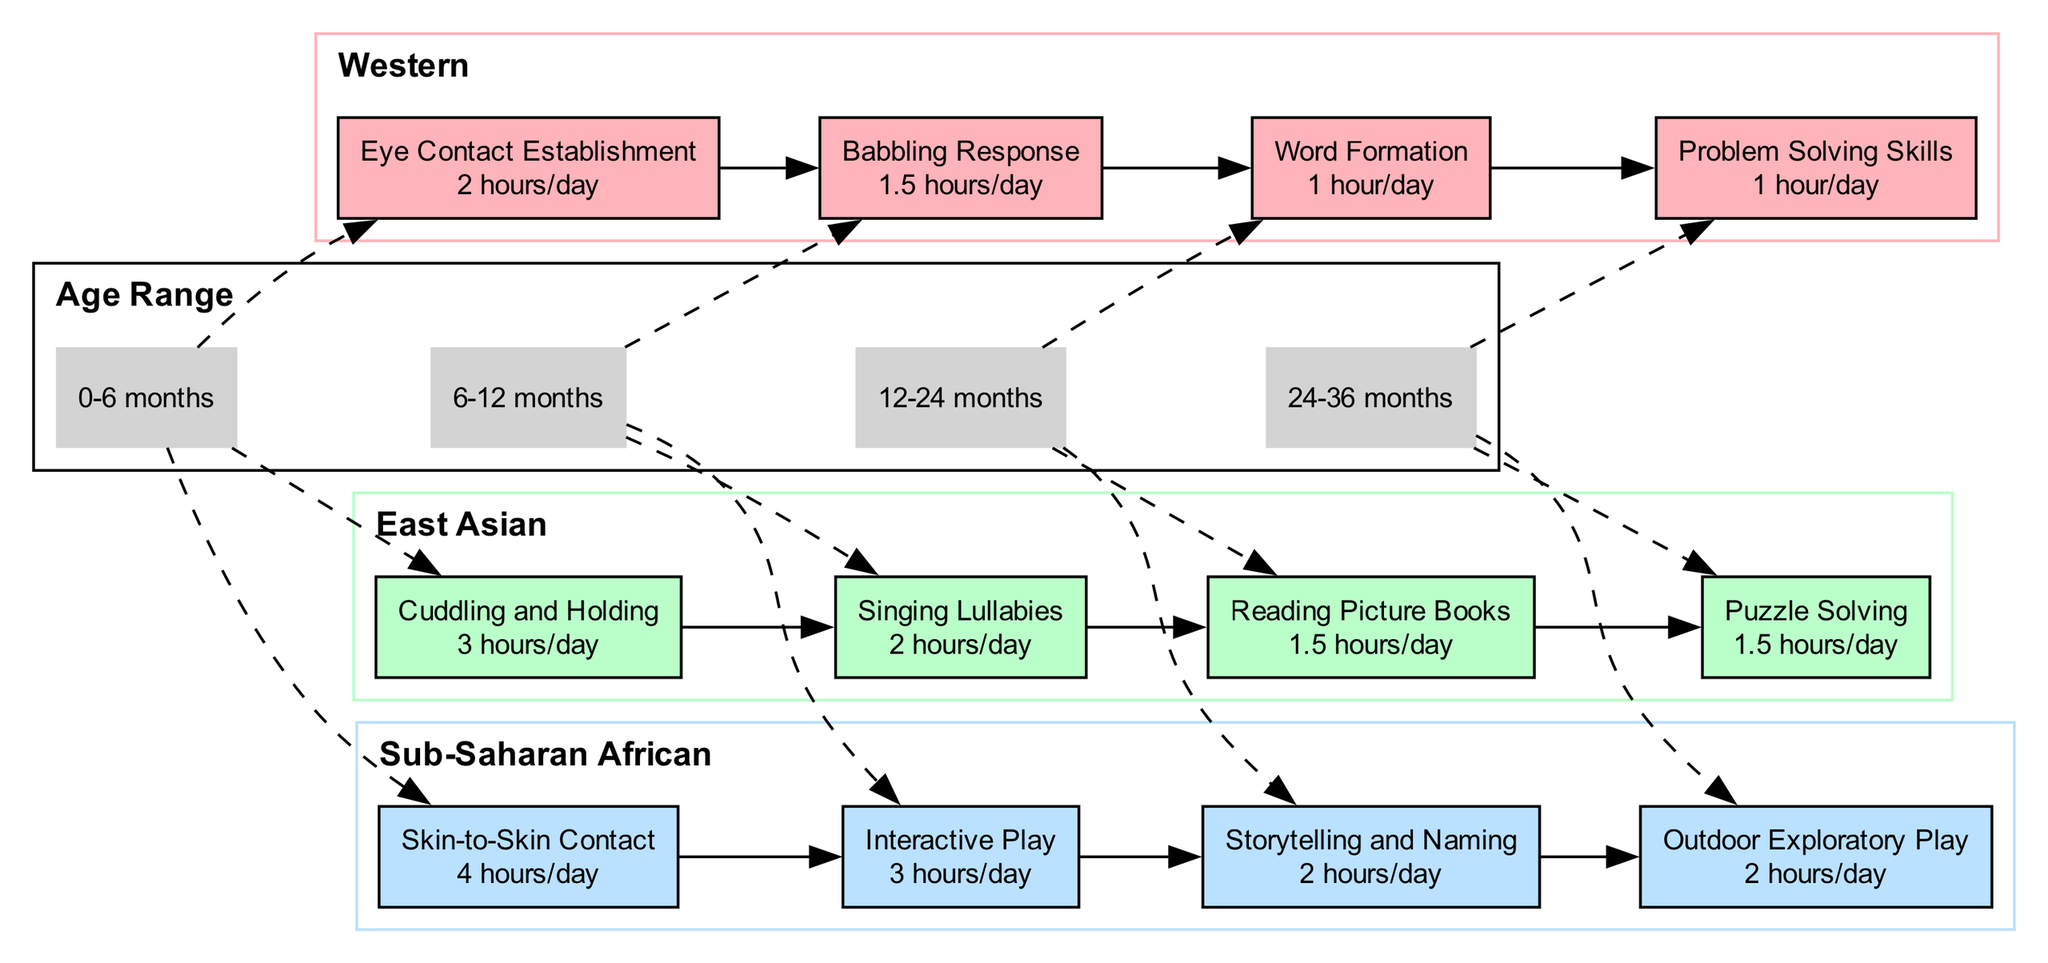What is the interaction time for eye contact establishment in the Western society? The diagram shows that the milestone for eye contact establishment in the Western society is linked to the age range of 0-6 months, where the interaction time is specified as 2 hours/day.
Answer: 2 hours/day Which society has the highest interaction time for cuddling and holding? By examining the milestones for the age range of 0-6 months, it is noted that Sub-Saharan African society has the highest interaction time for cuddling and holding, which is 4 hours/day.
Answer: 4 hours/day What are the milestones for East Asian society during the age range of 12-24 months? The diagram indicates that during the age range of 12-24 months, East Asian society's milestones include Reading Picture Books with an interaction time of 1.5 hours/day.
Answer: Reading Picture Books, 1.5 hours/day How many societies are represented in the diagram? The diagram features three societies: Western, East Asian, and Sub-Saharan African. Thus, counting these distinct groups gives us a total of 3 societies.
Answer: 3 Which age range has the lowest interaction time for Word Formation in the Western society? The age range of 12-24 months is specified for the milestone Word Formation in Western society, where the interaction time is recorded as 1 hour/day, making it the lowest time indicated for this society.
Answer: 1 hour/day What is the main milestone activity for Sub-Saharan African society during the 24-36 months age range? The diagram shows that the main milestone activity for Sub-Saharan African society during the 24-36 months age range is Outdoor Exploratory Play, with an interaction time of 2 hours/day.
Answer: Outdoor Exploratory Play, 2 hours/day What is the correlation between age ranges and interaction times in the Western society? In the Western society, as age ranges progress from 0-6 months to 6-12 months and beyond, interaction times generally decrease, starting from 2 hours/day to 1 hour/day for subsequent milestones.
Answer: Decrease Which milestone represents the longest interaction time for the East Asian society? After analyzing the diagram, it is clear that the East Asian society has the longest interaction time for Singing Lullabies at 2 hours/day in the age range of 6-12 months.
Answer: Singing Lullabies, 2 hours/day 